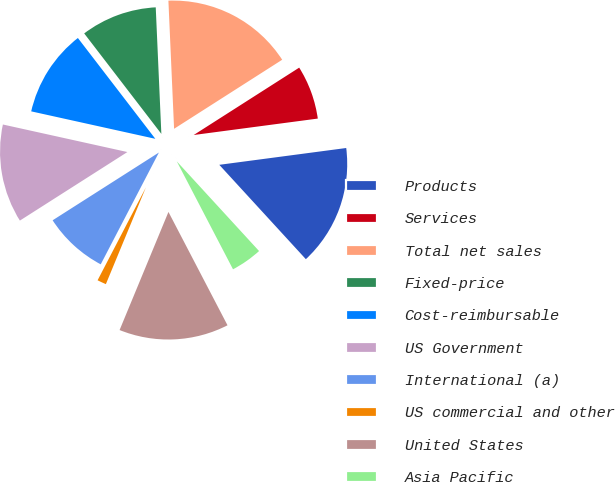Convert chart to OTSL. <chart><loc_0><loc_0><loc_500><loc_500><pie_chart><fcel>Products<fcel>Services<fcel>Total net sales<fcel>Fixed-price<fcel>Cost-reimbursable<fcel>US Government<fcel>International (a)<fcel>US commercial and other<fcel>United States<fcel>Asia Pacific<nl><fcel>15.28%<fcel>6.95%<fcel>16.66%<fcel>9.72%<fcel>11.11%<fcel>12.5%<fcel>8.33%<fcel>1.39%<fcel>13.89%<fcel>4.17%<nl></chart> 